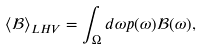<formula> <loc_0><loc_0><loc_500><loc_500>\langle \mathcal { B } \rangle _ { L H V } = \int _ { \Omega } d \omega p ( \omega ) \mathcal { B } ( \omega ) ,</formula> 